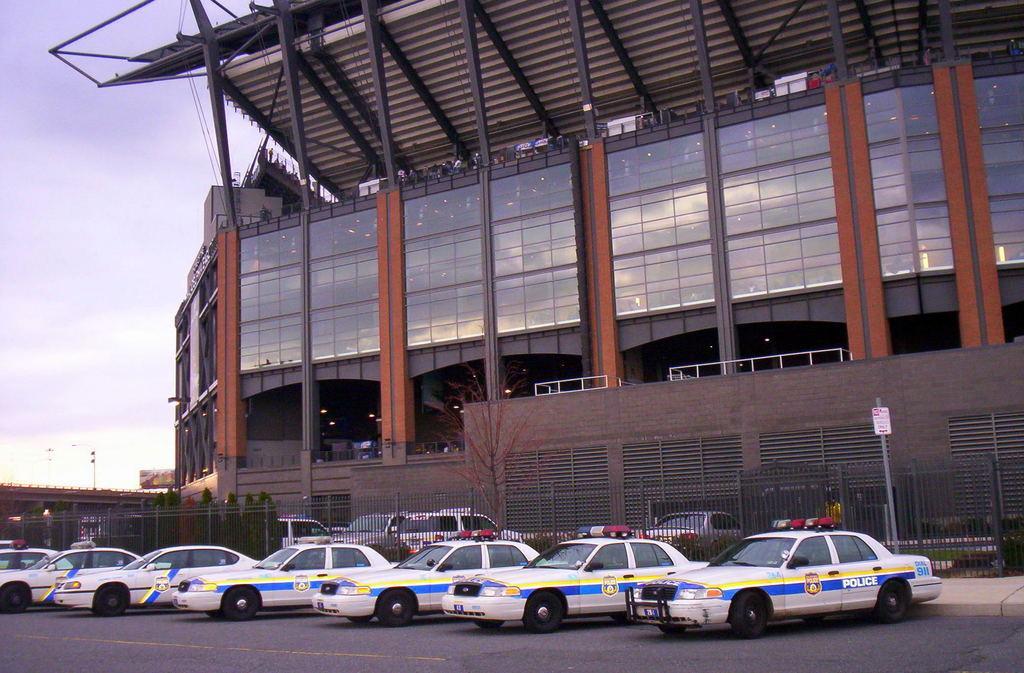Please provide a concise description of this image. In this image, we can see vehicles on the road and in the background, there is a building and we can see a board, poles, trees, fence and at the top, there is sky. 